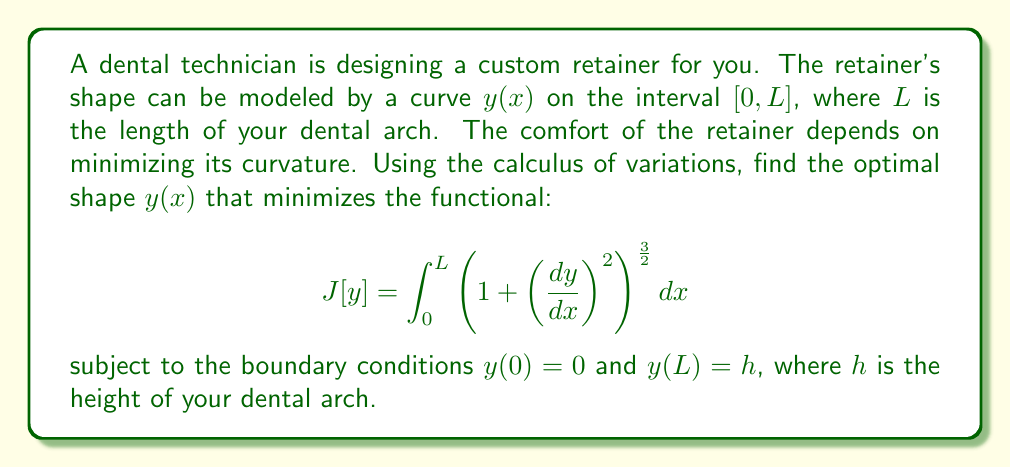Teach me how to tackle this problem. To solve this problem, we'll use the Euler-Lagrange equation from the calculus of variations:

$$ \frac{\partial F}{\partial y} - \frac{d}{dx}\left(\frac{\partial F}{\partial y'}\right) = 0 $$

where $F(x,y,y') = \left(1 + \left(\frac{dy}{dx}\right)^2\right)^{\frac{3}{2}}$.

1) First, calculate $\frac{\partial F}{\partial y}$:
   $\frac{\partial F}{\partial y} = 0$

2) Next, calculate $\frac{\partial F}{\partial y'}$:
   $\frac{\partial F}{\partial y'} = 3(1+y'^2)^{\frac{1}{2}}y'$

3) Now, calculate $\frac{d}{dx}\left(\frac{\partial F}{\partial y'}\right)$:
   $\frac{d}{dx}\left(\frac{\partial F}{\partial y'}\right) = \frac{d}{dx}\left(3(1+y'^2)^{\frac{1}{2}}y'\right) = 3\frac{d}{dx}\left((1+y'^2)^{\frac{1}{2}}y'\right)$

4) Substitute these into the Euler-Lagrange equation:
   $0 - 3\frac{d}{dx}\left((1+y'^2)^{\frac{1}{2}}y'\right) = 0$

5) Simplify:
   $\frac{d}{dx}\left((1+y'^2)^{\frac{1}{2}}y'\right) = 0$

6) Integrate both sides:
   $(1+y'^2)^{\frac{1}{2}}y' = C$, where $C$ is a constant of integration

7) Square both sides:
   $(1+y'^2)y'^2 = C^2$

8) Simplify:
   $y'^2 + y'^4 = C^2$

9) Solve for $y'$:
   $y' = \pm \frac{C}{\sqrt{1-C^2}}$

10) Integrate to get $y$:
    $y = \pm \frac{C}{\sqrt{1-C^2}}x + D$, where $D$ is another constant of integration

11) Apply the boundary conditions:
    $y(0) = 0$ implies $D = 0$
    $y(L) = h$ implies $\pm \frac{CL}{\sqrt{1-C^2}} = h$

12) Solve for $C$:
    $C = \frac{h}{\sqrt{L^2+h^2}}$

Therefore, the optimal shape of the retainer is given by:

$$ y(x) = \frac{hx}{L} $$

This represents a straight line from $(0,0)$ to $(L,h)$.
Answer: The optimal shape of the retainer that minimizes curvature is a straight line given by the equation:

$$ y(x) = \frac{hx}{L} $$

where $L$ is the length of the dental arch and $h$ is the height of the dental arch. 